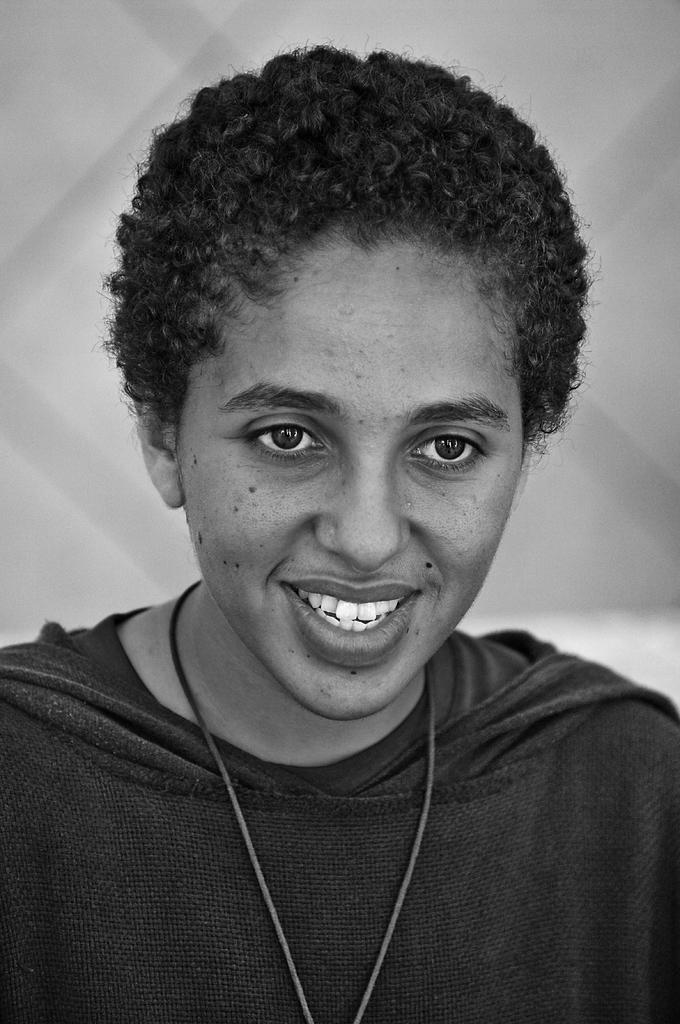What is the color scheme of the image? The image is black and white. Can you describe the person in the image? There is a person in the image, and they have a smiley face. What is the background of the image? The background of the image is white. What type of haircut does the person have in the image? There is no information about the person's haircut in the image, as it is black and white and does not show details about the person's hair. 